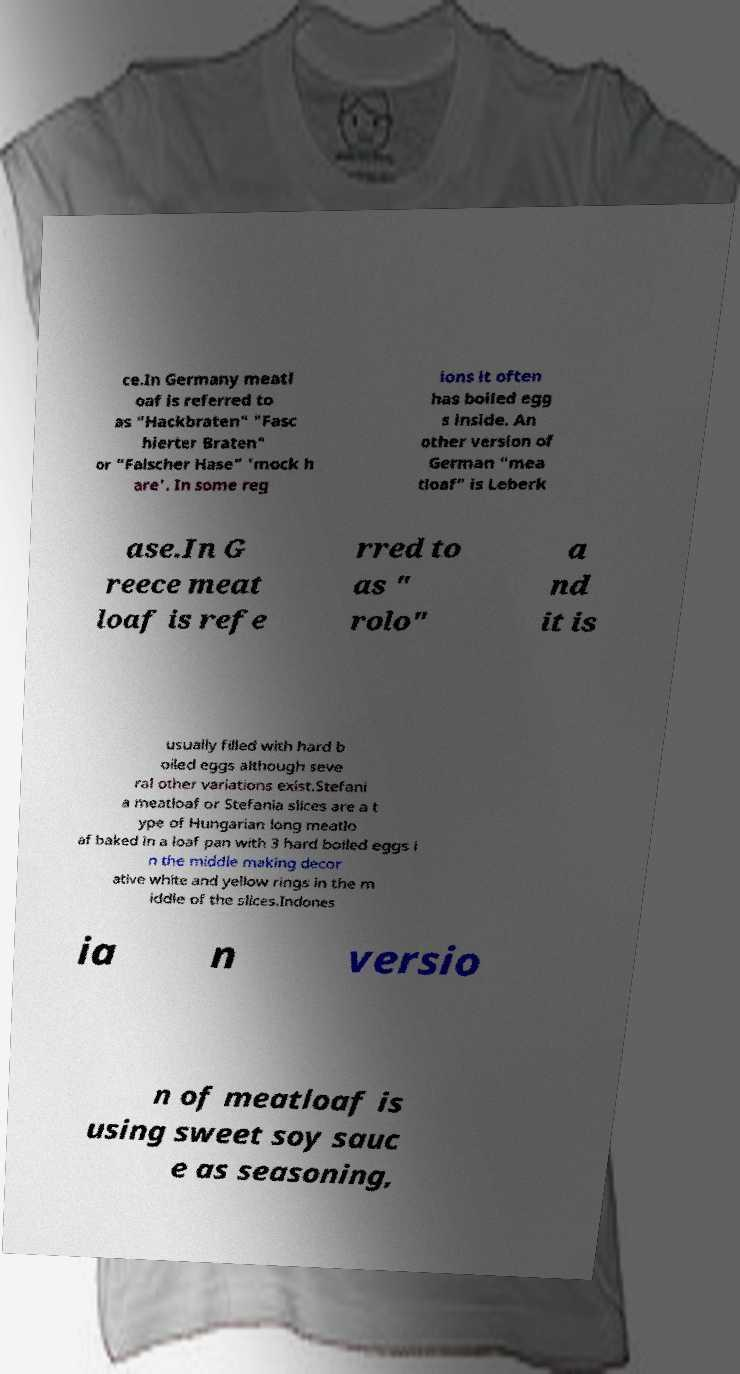Can you accurately transcribe the text from the provided image for me? ce.In Germany meatl oaf is referred to as "Hackbraten" "Fasc hierter Braten" or "Falscher Hase" 'mock h are'. In some reg ions it often has boiled egg s inside. An other version of German "mea tloaf" is Leberk ase.In G reece meat loaf is refe rred to as " rolo" a nd it is usually filled with hard b oiled eggs although seve ral other variations exist.Stefani a meatloaf or Stefania slices are a t ype of Hungarian long meatlo af baked in a loaf pan with 3 hard boiled eggs i n the middle making decor ative white and yellow rings in the m iddle of the slices.Indones ia n versio n of meatloaf is using sweet soy sauc e as seasoning, 